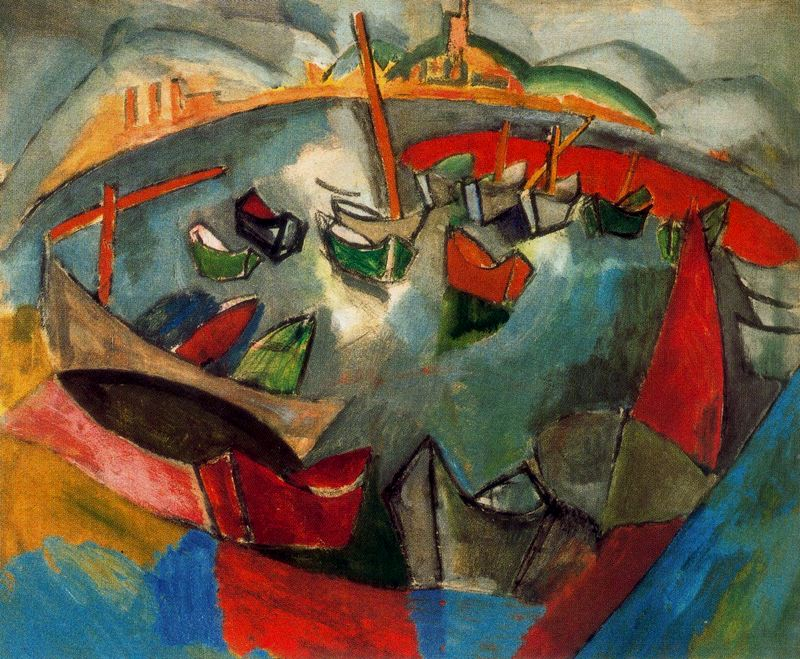What might the array of bold colors suggest about the scene depicted? The bold colors likely symbolize the vibrant, ever-changing life within the harbor. Red and orange might represent the energy and intensity, while blues and greens could denote the natural elements like water and land. This color usage enhances the viewer's emotional engagement with the painting, suggesting a place bustling with activity and life. 